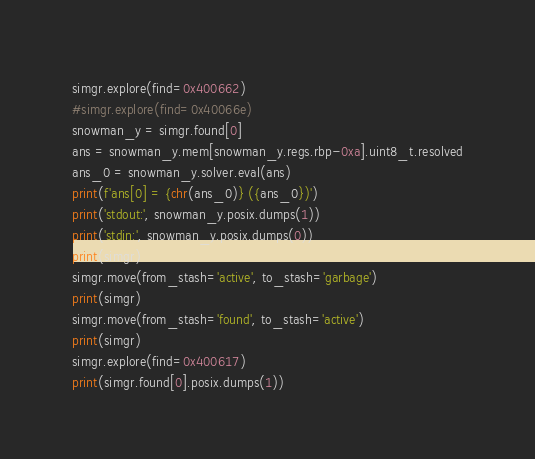Convert code to text. <code><loc_0><loc_0><loc_500><loc_500><_Python_>simgr.explore(find=0x400662)
#simgr.explore(find=0x40066e)
snowman_y = simgr.found[0]
ans = snowman_y.mem[snowman_y.regs.rbp-0xa].uint8_t.resolved
ans_0 = snowman_y.solver.eval(ans)
print(f'ans[0] = {chr(ans_0)} ({ans_0})')
print('stdout:', snowman_y.posix.dumps(1))
print('stdin:', snowman_y.posix.dumps(0))
print(simgr)
simgr.move(from_stash='active', to_stash='garbage')
print(simgr)
simgr.move(from_stash='found', to_stash='active')
print(simgr)
simgr.explore(find=0x400617)
print(simgr.found[0].posix.dumps(1))
</code> 